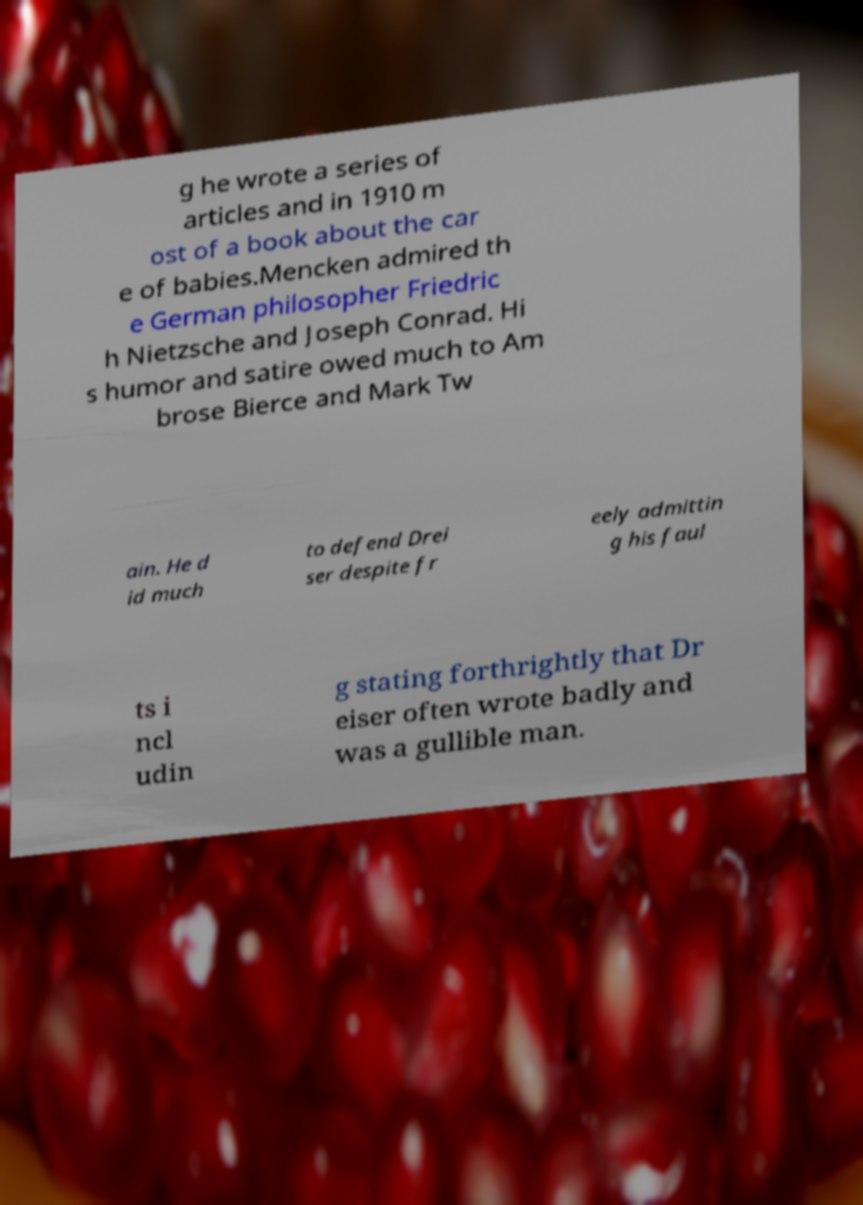Please identify and transcribe the text found in this image. g he wrote a series of articles and in 1910 m ost of a book about the car e of babies.Mencken admired th e German philosopher Friedric h Nietzsche and Joseph Conrad. Hi s humor and satire owed much to Am brose Bierce and Mark Tw ain. He d id much to defend Drei ser despite fr eely admittin g his faul ts i ncl udin g stating forthrightly that Dr eiser often wrote badly and was a gullible man. 